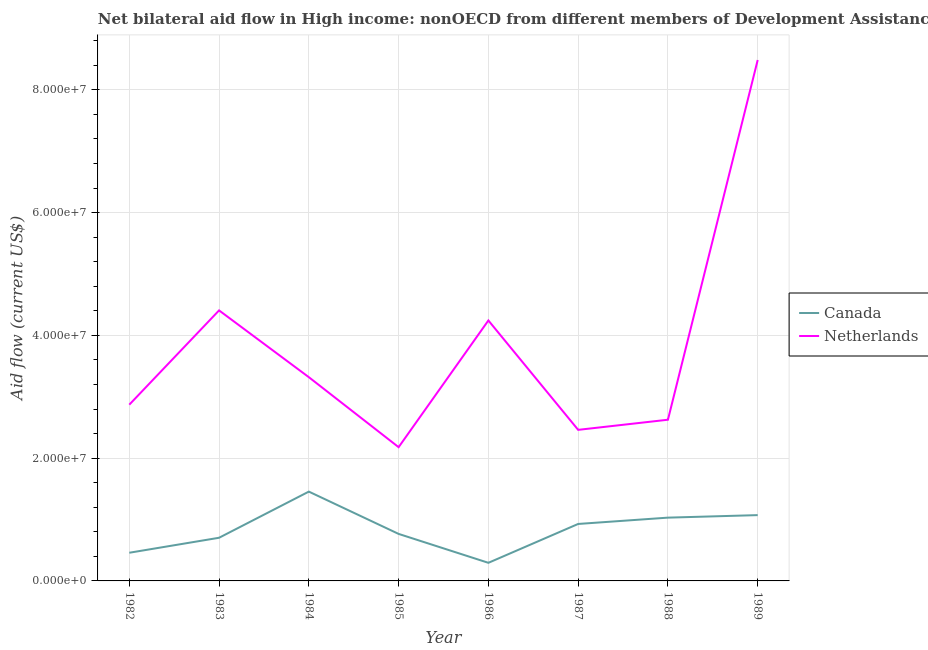Does the line corresponding to amount of aid given by netherlands intersect with the line corresponding to amount of aid given by canada?
Ensure brevity in your answer.  No. What is the amount of aid given by canada in 1988?
Keep it short and to the point. 1.03e+07. Across all years, what is the maximum amount of aid given by canada?
Keep it short and to the point. 1.46e+07. Across all years, what is the minimum amount of aid given by netherlands?
Your answer should be compact. 2.18e+07. In which year was the amount of aid given by netherlands minimum?
Make the answer very short. 1985. What is the total amount of aid given by netherlands in the graph?
Keep it short and to the point. 3.06e+08. What is the difference between the amount of aid given by canada in 1982 and that in 1987?
Your answer should be compact. -4.69e+06. What is the difference between the amount of aid given by canada in 1986 and the amount of aid given by netherlands in 1983?
Your response must be concise. -4.11e+07. What is the average amount of aid given by netherlands per year?
Offer a terse response. 3.82e+07. In the year 1986, what is the difference between the amount of aid given by netherlands and amount of aid given by canada?
Your response must be concise. 3.95e+07. In how many years, is the amount of aid given by netherlands greater than 48000000 US$?
Offer a very short reply. 1. What is the ratio of the amount of aid given by canada in 1984 to that in 1987?
Your response must be concise. 1.57. Is the difference between the amount of aid given by canada in 1985 and 1987 greater than the difference between the amount of aid given by netherlands in 1985 and 1987?
Your response must be concise. Yes. What is the difference between the highest and the second highest amount of aid given by canada?
Your answer should be compact. 3.83e+06. What is the difference between the highest and the lowest amount of aid given by canada?
Keep it short and to the point. 1.16e+07. Does the amount of aid given by netherlands monotonically increase over the years?
Make the answer very short. No. Is the amount of aid given by canada strictly less than the amount of aid given by netherlands over the years?
Offer a very short reply. Yes. How many years are there in the graph?
Offer a terse response. 8. What is the difference between two consecutive major ticks on the Y-axis?
Make the answer very short. 2.00e+07. Where does the legend appear in the graph?
Offer a very short reply. Center right. What is the title of the graph?
Offer a very short reply. Net bilateral aid flow in High income: nonOECD from different members of Development Assistance Committee. Does "Public funds" appear as one of the legend labels in the graph?
Keep it short and to the point. No. What is the label or title of the Y-axis?
Your answer should be very brief. Aid flow (current US$). What is the Aid flow (current US$) in Canada in 1982?
Keep it short and to the point. 4.59e+06. What is the Aid flow (current US$) of Netherlands in 1982?
Your answer should be very brief. 2.87e+07. What is the Aid flow (current US$) of Canada in 1983?
Ensure brevity in your answer.  7.03e+06. What is the Aid flow (current US$) of Netherlands in 1983?
Offer a very short reply. 4.41e+07. What is the Aid flow (current US$) of Canada in 1984?
Offer a terse response. 1.46e+07. What is the Aid flow (current US$) in Netherlands in 1984?
Your answer should be compact. 3.32e+07. What is the Aid flow (current US$) in Canada in 1985?
Offer a very short reply. 7.66e+06. What is the Aid flow (current US$) in Netherlands in 1985?
Keep it short and to the point. 2.18e+07. What is the Aid flow (current US$) of Canada in 1986?
Ensure brevity in your answer.  2.95e+06. What is the Aid flow (current US$) in Netherlands in 1986?
Make the answer very short. 4.24e+07. What is the Aid flow (current US$) of Canada in 1987?
Keep it short and to the point. 9.28e+06. What is the Aid flow (current US$) in Netherlands in 1987?
Your response must be concise. 2.46e+07. What is the Aid flow (current US$) of Canada in 1988?
Keep it short and to the point. 1.03e+07. What is the Aid flow (current US$) in Netherlands in 1988?
Your answer should be compact. 2.63e+07. What is the Aid flow (current US$) in Canada in 1989?
Your response must be concise. 1.07e+07. What is the Aid flow (current US$) of Netherlands in 1989?
Provide a succinct answer. 8.49e+07. Across all years, what is the maximum Aid flow (current US$) of Canada?
Your answer should be compact. 1.46e+07. Across all years, what is the maximum Aid flow (current US$) in Netherlands?
Offer a terse response. 8.49e+07. Across all years, what is the minimum Aid flow (current US$) in Canada?
Keep it short and to the point. 2.95e+06. Across all years, what is the minimum Aid flow (current US$) of Netherlands?
Keep it short and to the point. 2.18e+07. What is the total Aid flow (current US$) of Canada in the graph?
Ensure brevity in your answer.  6.71e+07. What is the total Aid flow (current US$) in Netherlands in the graph?
Provide a succinct answer. 3.06e+08. What is the difference between the Aid flow (current US$) of Canada in 1982 and that in 1983?
Offer a terse response. -2.44e+06. What is the difference between the Aid flow (current US$) in Netherlands in 1982 and that in 1983?
Offer a very short reply. -1.54e+07. What is the difference between the Aid flow (current US$) of Canada in 1982 and that in 1984?
Keep it short and to the point. -9.96e+06. What is the difference between the Aid flow (current US$) of Netherlands in 1982 and that in 1984?
Provide a succinct answer. -4.48e+06. What is the difference between the Aid flow (current US$) in Canada in 1982 and that in 1985?
Provide a succinct answer. -3.07e+06. What is the difference between the Aid flow (current US$) in Netherlands in 1982 and that in 1985?
Keep it short and to the point. 6.92e+06. What is the difference between the Aid flow (current US$) in Canada in 1982 and that in 1986?
Give a very brief answer. 1.64e+06. What is the difference between the Aid flow (current US$) of Netherlands in 1982 and that in 1986?
Keep it short and to the point. -1.37e+07. What is the difference between the Aid flow (current US$) in Canada in 1982 and that in 1987?
Provide a succinct answer. -4.69e+06. What is the difference between the Aid flow (current US$) of Netherlands in 1982 and that in 1987?
Ensure brevity in your answer.  4.10e+06. What is the difference between the Aid flow (current US$) in Canada in 1982 and that in 1988?
Your answer should be compact. -5.72e+06. What is the difference between the Aid flow (current US$) in Netherlands in 1982 and that in 1988?
Your response must be concise. 2.45e+06. What is the difference between the Aid flow (current US$) of Canada in 1982 and that in 1989?
Ensure brevity in your answer.  -6.13e+06. What is the difference between the Aid flow (current US$) of Netherlands in 1982 and that in 1989?
Your answer should be very brief. -5.62e+07. What is the difference between the Aid flow (current US$) of Canada in 1983 and that in 1984?
Your response must be concise. -7.52e+06. What is the difference between the Aid flow (current US$) of Netherlands in 1983 and that in 1984?
Your answer should be compact. 1.09e+07. What is the difference between the Aid flow (current US$) in Canada in 1983 and that in 1985?
Your answer should be compact. -6.30e+05. What is the difference between the Aid flow (current US$) of Netherlands in 1983 and that in 1985?
Keep it short and to the point. 2.23e+07. What is the difference between the Aid flow (current US$) in Canada in 1983 and that in 1986?
Your response must be concise. 4.08e+06. What is the difference between the Aid flow (current US$) in Netherlands in 1983 and that in 1986?
Offer a very short reply. 1.64e+06. What is the difference between the Aid flow (current US$) of Canada in 1983 and that in 1987?
Your answer should be compact. -2.25e+06. What is the difference between the Aid flow (current US$) in Netherlands in 1983 and that in 1987?
Keep it short and to the point. 1.95e+07. What is the difference between the Aid flow (current US$) of Canada in 1983 and that in 1988?
Offer a terse response. -3.28e+06. What is the difference between the Aid flow (current US$) in Netherlands in 1983 and that in 1988?
Give a very brief answer. 1.78e+07. What is the difference between the Aid flow (current US$) of Canada in 1983 and that in 1989?
Provide a succinct answer. -3.69e+06. What is the difference between the Aid flow (current US$) in Netherlands in 1983 and that in 1989?
Make the answer very short. -4.08e+07. What is the difference between the Aid flow (current US$) in Canada in 1984 and that in 1985?
Give a very brief answer. 6.89e+06. What is the difference between the Aid flow (current US$) in Netherlands in 1984 and that in 1985?
Offer a very short reply. 1.14e+07. What is the difference between the Aid flow (current US$) in Canada in 1984 and that in 1986?
Ensure brevity in your answer.  1.16e+07. What is the difference between the Aid flow (current US$) of Netherlands in 1984 and that in 1986?
Your response must be concise. -9.24e+06. What is the difference between the Aid flow (current US$) of Canada in 1984 and that in 1987?
Provide a short and direct response. 5.27e+06. What is the difference between the Aid flow (current US$) of Netherlands in 1984 and that in 1987?
Keep it short and to the point. 8.58e+06. What is the difference between the Aid flow (current US$) of Canada in 1984 and that in 1988?
Provide a short and direct response. 4.24e+06. What is the difference between the Aid flow (current US$) in Netherlands in 1984 and that in 1988?
Your answer should be very brief. 6.93e+06. What is the difference between the Aid flow (current US$) of Canada in 1984 and that in 1989?
Provide a succinct answer. 3.83e+06. What is the difference between the Aid flow (current US$) of Netherlands in 1984 and that in 1989?
Make the answer very short. -5.17e+07. What is the difference between the Aid flow (current US$) in Canada in 1985 and that in 1986?
Your answer should be compact. 4.71e+06. What is the difference between the Aid flow (current US$) in Netherlands in 1985 and that in 1986?
Offer a very short reply. -2.06e+07. What is the difference between the Aid flow (current US$) of Canada in 1985 and that in 1987?
Keep it short and to the point. -1.62e+06. What is the difference between the Aid flow (current US$) of Netherlands in 1985 and that in 1987?
Keep it short and to the point. -2.82e+06. What is the difference between the Aid flow (current US$) of Canada in 1985 and that in 1988?
Make the answer very short. -2.65e+06. What is the difference between the Aid flow (current US$) in Netherlands in 1985 and that in 1988?
Make the answer very short. -4.47e+06. What is the difference between the Aid flow (current US$) in Canada in 1985 and that in 1989?
Give a very brief answer. -3.06e+06. What is the difference between the Aid flow (current US$) in Netherlands in 1985 and that in 1989?
Give a very brief answer. -6.31e+07. What is the difference between the Aid flow (current US$) of Canada in 1986 and that in 1987?
Provide a short and direct response. -6.33e+06. What is the difference between the Aid flow (current US$) of Netherlands in 1986 and that in 1987?
Ensure brevity in your answer.  1.78e+07. What is the difference between the Aid flow (current US$) of Canada in 1986 and that in 1988?
Provide a succinct answer. -7.36e+06. What is the difference between the Aid flow (current US$) in Netherlands in 1986 and that in 1988?
Keep it short and to the point. 1.62e+07. What is the difference between the Aid flow (current US$) of Canada in 1986 and that in 1989?
Offer a very short reply. -7.77e+06. What is the difference between the Aid flow (current US$) of Netherlands in 1986 and that in 1989?
Ensure brevity in your answer.  -4.24e+07. What is the difference between the Aid flow (current US$) of Canada in 1987 and that in 1988?
Keep it short and to the point. -1.03e+06. What is the difference between the Aid flow (current US$) in Netherlands in 1987 and that in 1988?
Keep it short and to the point. -1.65e+06. What is the difference between the Aid flow (current US$) in Canada in 1987 and that in 1989?
Your response must be concise. -1.44e+06. What is the difference between the Aid flow (current US$) of Netherlands in 1987 and that in 1989?
Keep it short and to the point. -6.02e+07. What is the difference between the Aid flow (current US$) of Canada in 1988 and that in 1989?
Make the answer very short. -4.10e+05. What is the difference between the Aid flow (current US$) of Netherlands in 1988 and that in 1989?
Provide a short and direct response. -5.86e+07. What is the difference between the Aid flow (current US$) of Canada in 1982 and the Aid flow (current US$) of Netherlands in 1983?
Keep it short and to the point. -3.95e+07. What is the difference between the Aid flow (current US$) in Canada in 1982 and the Aid flow (current US$) in Netherlands in 1984?
Your answer should be very brief. -2.86e+07. What is the difference between the Aid flow (current US$) of Canada in 1982 and the Aid flow (current US$) of Netherlands in 1985?
Ensure brevity in your answer.  -1.72e+07. What is the difference between the Aid flow (current US$) in Canada in 1982 and the Aid flow (current US$) in Netherlands in 1986?
Make the answer very short. -3.78e+07. What is the difference between the Aid flow (current US$) in Canada in 1982 and the Aid flow (current US$) in Netherlands in 1987?
Make the answer very short. -2.00e+07. What is the difference between the Aid flow (current US$) of Canada in 1982 and the Aid flow (current US$) of Netherlands in 1988?
Your response must be concise. -2.17e+07. What is the difference between the Aid flow (current US$) in Canada in 1982 and the Aid flow (current US$) in Netherlands in 1989?
Your response must be concise. -8.03e+07. What is the difference between the Aid flow (current US$) in Canada in 1983 and the Aid flow (current US$) in Netherlands in 1984?
Give a very brief answer. -2.62e+07. What is the difference between the Aid flow (current US$) in Canada in 1983 and the Aid flow (current US$) in Netherlands in 1985?
Offer a terse response. -1.48e+07. What is the difference between the Aid flow (current US$) in Canada in 1983 and the Aid flow (current US$) in Netherlands in 1986?
Your answer should be compact. -3.54e+07. What is the difference between the Aid flow (current US$) in Canada in 1983 and the Aid flow (current US$) in Netherlands in 1987?
Ensure brevity in your answer.  -1.76e+07. What is the difference between the Aid flow (current US$) in Canada in 1983 and the Aid flow (current US$) in Netherlands in 1988?
Your answer should be very brief. -1.92e+07. What is the difference between the Aid flow (current US$) of Canada in 1983 and the Aid flow (current US$) of Netherlands in 1989?
Your answer should be very brief. -7.78e+07. What is the difference between the Aid flow (current US$) of Canada in 1984 and the Aid flow (current US$) of Netherlands in 1985?
Ensure brevity in your answer.  -7.24e+06. What is the difference between the Aid flow (current US$) in Canada in 1984 and the Aid flow (current US$) in Netherlands in 1986?
Your response must be concise. -2.79e+07. What is the difference between the Aid flow (current US$) in Canada in 1984 and the Aid flow (current US$) in Netherlands in 1987?
Ensure brevity in your answer.  -1.01e+07. What is the difference between the Aid flow (current US$) in Canada in 1984 and the Aid flow (current US$) in Netherlands in 1988?
Your response must be concise. -1.17e+07. What is the difference between the Aid flow (current US$) in Canada in 1984 and the Aid flow (current US$) in Netherlands in 1989?
Your answer should be very brief. -7.03e+07. What is the difference between the Aid flow (current US$) of Canada in 1985 and the Aid flow (current US$) of Netherlands in 1986?
Your response must be concise. -3.48e+07. What is the difference between the Aid flow (current US$) in Canada in 1985 and the Aid flow (current US$) in Netherlands in 1987?
Provide a succinct answer. -1.70e+07. What is the difference between the Aid flow (current US$) in Canada in 1985 and the Aid flow (current US$) in Netherlands in 1988?
Give a very brief answer. -1.86e+07. What is the difference between the Aid flow (current US$) in Canada in 1985 and the Aid flow (current US$) in Netherlands in 1989?
Ensure brevity in your answer.  -7.72e+07. What is the difference between the Aid flow (current US$) of Canada in 1986 and the Aid flow (current US$) of Netherlands in 1987?
Your response must be concise. -2.17e+07. What is the difference between the Aid flow (current US$) in Canada in 1986 and the Aid flow (current US$) in Netherlands in 1988?
Offer a very short reply. -2.33e+07. What is the difference between the Aid flow (current US$) in Canada in 1986 and the Aid flow (current US$) in Netherlands in 1989?
Offer a terse response. -8.19e+07. What is the difference between the Aid flow (current US$) of Canada in 1987 and the Aid flow (current US$) of Netherlands in 1988?
Give a very brief answer. -1.70e+07. What is the difference between the Aid flow (current US$) in Canada in 1987 and the Aid flow (current US$) in Netherlands in 1989?
Make the answer very short. -7.56e+07. What is the difference between the Aid flow (current US$) in Canada in 1988 and the Aid flow (current US$) in Netherlands in 1989?
Keep it short and to the point. -7.46e+07. What is the average Aid flow (current US$) in Canada per year?
Provide a succinct answer. 8.39e+06. What is the average Aid flow (current US$) in Netherlands per year?
Offer a very short reply. 3.82e+07. In the year 1982, what is the difference between the Aid flow (current US$) in Canada and Aid flow (current US$) in Netherlands?
Offer a terse response. -2.41e+07. In the year 1983, what is the difference between the Aid flow (current US$) in Canada and Aid flow (current US$) in Netherlands?
Keep it short and to the point. -3.70e+07. In the year 1984, what is the difference between the Aid flow (current US$) of Canada and Aid flow (current US$) of Netherlands?
Ensure brevity in your answer.  -1.86e+07. In the year 1985, what is the difference between the Aid flow (current US$) in Canada and Aid flow (current US$) in Netherlands?
Give a very brief answer. -1.41e+07. In the year 1986, what is the difference between the Aid flow (current US$) of Canada and Aid flow (current US$) of Netherlands?
Give a very brief answer. -3.95e+07. In the year 1987, what is the difference between the Aid flow (current US$) of Canada and Aid flow (current US$) of Netherlands?
Ensure brevity in your answer.  -1.53e+07. In the year 1988, what is the difference between the Aid flow (current US$) in Canada and Aid flow (current US$) in Netherlands?
Your answer should be very brief. -1.60e+07. In the year 1989, what is the difference between the Aid flow (current US$) in Canada and Aid flow (current US$) in Netherlands?
Your answer should be compact. -7.41e+07. What is the ratio of the Aid flow (current US$) in Canada in 1982 to that in 1983?
Provide a short and direct response. 0.65. What is the ratio of the Aid flow (current US$) of Netherlands in 1982 to that in 1983?
Provide a short and direct response. 0.65. What is the ratio of the Aid flow (current US$) in Canada in 1982 to that in 1984?
Ensure brevity in your answer.  0.32. What is the ratio of the Aid flow (current US$) of Netherlands in 1982 to that in 1984?
Your response must be concise. 0.86. What is the ratio of the Aid flow (current US$) of Canada in 1982 to that in 1985?
Offer a very short reply. 0.6. What is the ratio of the Aid flow (current US$) of Netherlands in 1982 to that in 1985?
Your answer should be very brief. 1.32. What is the ratio of the Aid flow (current US$) in Canada in 1982 to that in 1986?
Give a very brief answer. 1.56. What is the ratio of the Aid flow (current US$) of Netherlands in 1982 to that in 1986?
Provide a succinct answer. 0.68. What is the ratio of the Aid flow (current US$) in Canada in 1982 to that in 1987?
Provide a short and direct response. 0.49. What is the ratio of the Aid flow (current US$) of Netherlands in 1982 to that in 1987?
Provide a short and direct response. 1.17. What is the ratio of the Aid flow (current US$) of Canada in 1982 to that in 1988?
Make the answer very short. 0.45. What is the ratio of the Aid flow (current US$) in Netherlands in 1982 to that in 1988?
Provide a short and direct response. 1.09. What is the ratio of the Aid flow (current US$) in Canada in 1982 to that in 1989?
Provide a succinct answer. 0.43. What is the ratio of the Aid flow (current US$) in Netherlands in 1982 to that in 1989?
Provide a succinct answer. 0.34. What is the ratio of the Aid flow (current US$) in Canada in 1983 to that in 1984?
Provide a succinct answer. 0.48. What is the ratio of the Aid flow (current US$) of Netherlands in 1983 to that in 1984?
Make the answer very short. 1.33. What is the ratio of the Aid flow (current US$) of Canada in 1983 to that in 1985?
Keep it short and to the point. 0.92. What is the ratio of the Aid flow (current US$) in Netherlands in 1983 to that in 1985?
Ensure brevity in your answer.  2.02. What is the ratio of the Aid flow (current US$) in Canada in 1983 to that in 1986?
Make the answer very short. 2.38. What is the ratio of the Aid flow (current US$) of Netherlands in 1983 to that in 1986?
Offer a very short reply. 1.04. What is the ratio of the Aid flow (current US$) in Canada in 1983 to that in 1987?
Your response must be concise. 0.76. What is the ratio of the Aid flow (current US$) in Netherlands in 1983 to that in 1987?
Make the answer very short. 1.79. What is the ratio of the Aid flow (current US$) of Canada in 1983 to that in 1988?
Provide a succinct answer. 0.68. What is the ratio of the Aid flow (current US$) in Netherlands in 1983 to that in 1988?
Your response must be concise. 1.68. What is the ratio of the Aid flow (current US$) of Canada in 1983 to that in 1989?
Offer a very short reply. 0.66. What is the ratio of the Aid flow (current US$) in Netherlands in 1983 to that in 1989?
Your response must be concise. 0.52. What is the ratio of the Aid flow (current US$) of Canada in 1984 to that in 1985?
Offer a very short reply. 1.9. What is the ratio of the Aid flow (current US$) in Netherlands in 1984 to that in 1985?
Provide a short and direct response. 1.52. What is the ratio of the Aid flow (current US$) of Canada in 1984 to that in 1986?
Your answer should be very brief. 4.93. What is the ratio of the Aid flow (current US$) in Netherlands in 1984 to that in 1986?
Give a very brief answer. 0.78. What is the ratio of the Aid flow (current US$) in Canada in 1984 to that in 1987?
Your answer should be very brief. 1.57. What is the ratio of the Aid flow (current US$) in Netherlands in 1984 to that in 1987?
Your answer should be compact. 1.35. What is the ratio of the Aid flow (current US$) of Canada in 1984 to that in 1988?
Give a very brief answer. 1.41. What is the ratio of the Aid flow (current US$) in Netherlands in 1984 to that in 1988?
Provide a short and direct response. 1.26. What is the ratio of the Aid flow (current US$) of Canada in 1984 to that in 1989?
Your response must be concise. 1.36. What is the ratio of the Aid flow (current US$) of Netherlands in 1984 to that in 1989?
Offer a terse response. 0.39. What is the ratio of the Aid flow (current US$) in Canada in 1985 to that in 1986?
Make the answer very short. 2.6. What is the ratio of the Aid flow (current US$) in Netherlands in 1985 to that in 1986?
Provide a succinct answer. 0.51. What is the ratio of the Aid flow (current US$) of Canada in 1985 to that in 1987?
Your response must be concise. 0.83. What is the ratio of the Aid flow (current US$) of Netherlands in 1985 to that in 1987?
Offer a terse response. 0.89. What is the ratio of the Aid flow (current US$) of Canada in 1985 to that in 1988?
Offer a terse response. 0.74. What is the ratio of the Aid flow (current US$) of Netherlands in 1985 to that in 1988?
Your answer should be compact. 0.83. What is the ratio of the Aid flow (current US$) in Canada in 1985 to that in 1989?
Give a very brief answer. 0.71. What is the ratio of the Aid flow (current US$) in Netherlands in 1985 to that in 1989?
Give a very brief answer. 0.26. What is the ratio of the Aid flow (current US$) of Canada in 1986 to that in 1987?
Give a very brief answer. 0.32. What is the ratio of the Aid flow (current US$) in Netherlands in 1986 to that in 1987?
Provide a short and direct response. 1.72. What is the ratio of the Aid flow (current US$) in Canada in 1986 to that in 1988?
Ensure brevity in your answer.  0.29. What is the ratio of the Aid flow (current US$) of Netherlands in 1986 to that in 1988?
Your response must be concise. 1.62. What is the ratio of the Aid flow (current US$) of Canada in 1986 to that in 1989?
Provide a succinct answer. 0.28. What is the ratio of the Aid flow (current US$) of Canada in 1987 to that in 1988?
Provide a succinct answer. 0.9. What is the ratio of the Aid flow (current US$) of Netherlands in 1987 to that in 1988?
Your answer should be compact. 0.94. What is the ratio of the Aid flow (current US$) of Canada in 1987 to that in 1989?
Provide a short and direct response. 0.87. What is the ratio of the Aid flow (current US$) of Netherlands in 1987 to that in 1989?
Your answer should be very brief. 0.29. What is the ratio of the Aid flow (current US$) in Canada in 1988 to that in 1989?
Ensure brevity in your answer.  0.96. What is the ratio of the Aid flow (current US$) in Netherlands in 1988 to that in 1989?
Keep it short and to the point. 0.31. What is the difference between the highest and the second highest Aid flow (current US$) in Canada?
Provide a succinct answer. 3.83e+06. What is the difference between the highest and the second highest Aid flow (current US$) of Netherlands?
Provide a short and direct response. 4.08e+07. What is the difference between the highest and the lowest Aid flow (current US$) of Canada?
Ensure brevity in your answer.  1.16e+07. What is the difference between the highest and the lowest Aid flow (current US$) in Netherlands?
Your answer should be very brief. 6.31e+07. 